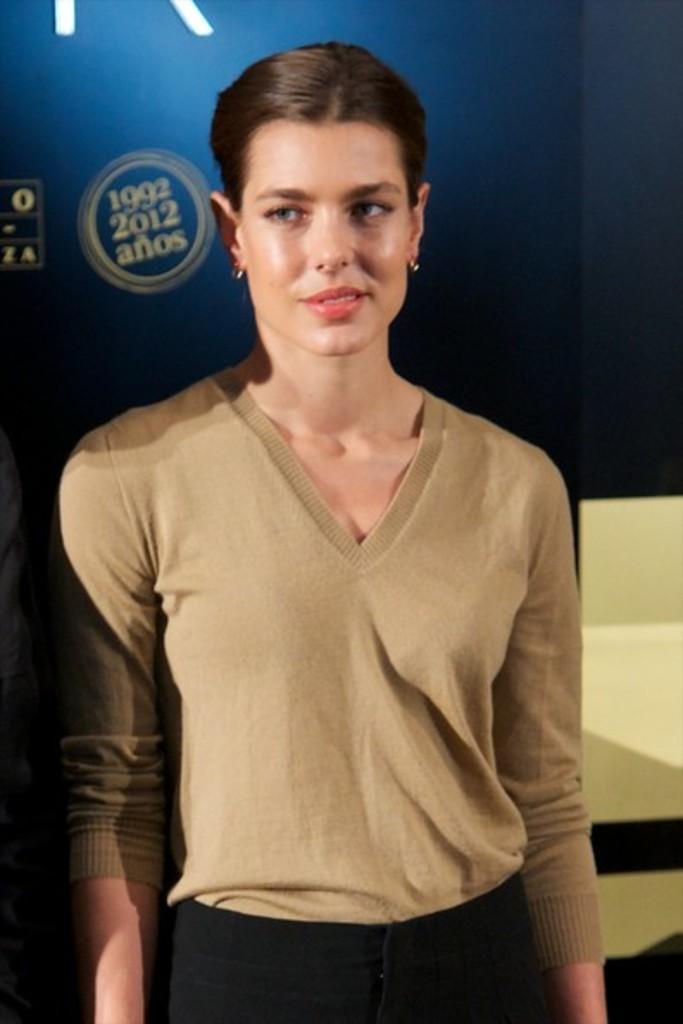Could you give a brief overview of what you see in this image? The woman in brown T-shirt and black pant is standing in the middle of the picture. Behind her, we see a blue board with some text written on it. Beside her, we see a staircase. 